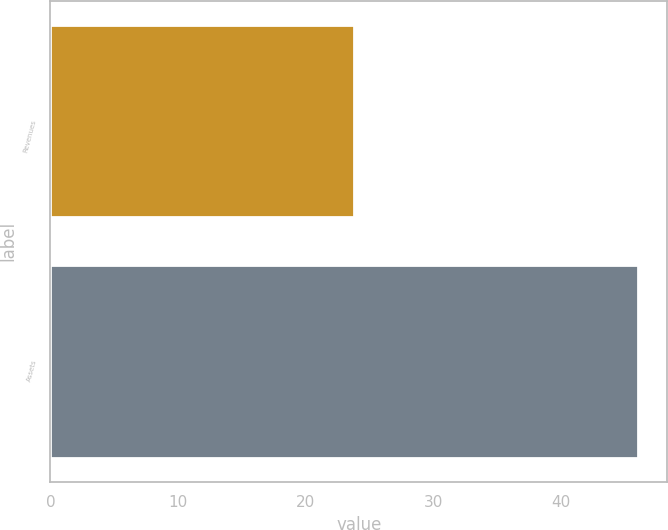Convert chart to OTSL. <chart><loc_0><loc_0><loc_500><loc_500><bar_chart><fcel>Revenues<fcel>Assets<nl><fcel>23.8<fcel>46<nl></chart> 